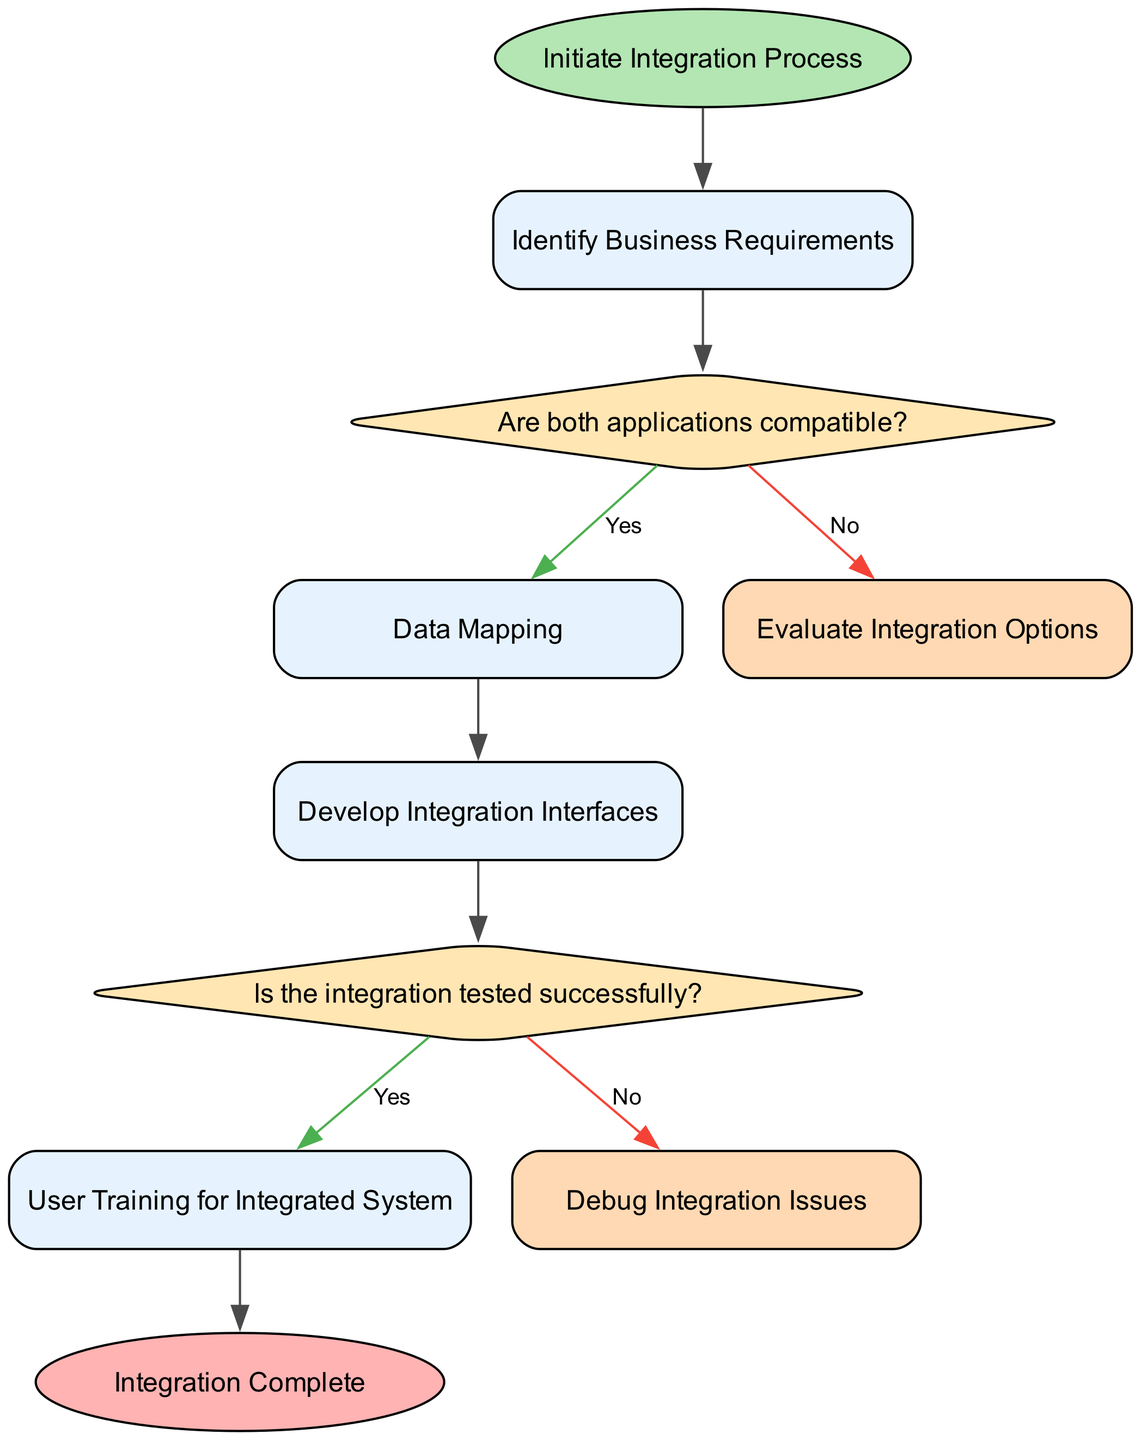What is the first step in the integration process? The diagram starts with the node labeled "Initiate Integration Process," which indicates it's the first step in the flow.
Answer: Initiate Integration Process How many decision points are present in the flow chart? By examining the diagram, there are two decision points: "Are both applications compatible?" and "Is the integration tested successfully?" This totals two decision points.
Answer: 2 What happens if the applications are not compatible? According to the flow chart, if the applications are not compatible, the process directs to the "Evaluate Integration Options" step.
Answer: Evaluate Integration Options What is the last step in the integration process? The final node in the flow chart is marked as "Integration Complete," indicating the end of the merging process.
Answer: Integration Complete Which step follows "Data Mapping"? After "Data Mapping," the next step outlined in the diagram is "Develop Integration Interfaces," indicating the sequence of actions after mapping.
Answer: Develop Integration Interfaces If the integration is not tested successfully, what action is taken? The flow chart specifies that if integration testing is unsuccessful, the next action is to "Debug Integration Issues," highlighting the approach to troubleshoot.
Answer: Debug Integration Issues What is the purpose of the "User Training for Integrated System" node? This node indicates a key part of the process aimed at preparing users to effectively use the newly integrated system after its deployment.
Answer: User Training for Integrated System What node is directly connected to the "Develop Integration Interfaces" step? Based on the flowchart, "Develop Integration Interfaces" is directly followed by a decision node labeled "Is the integration tested successfully?" hence establishing the connection.
Answer: Is the integration tested successfully? What color is used for the decision nodes in the flow chart? The decision nodes are represented in a yellowish color (#FFE6B3) in the flow chart style, denoting their special function in the process.
Answer: Yellowish color 